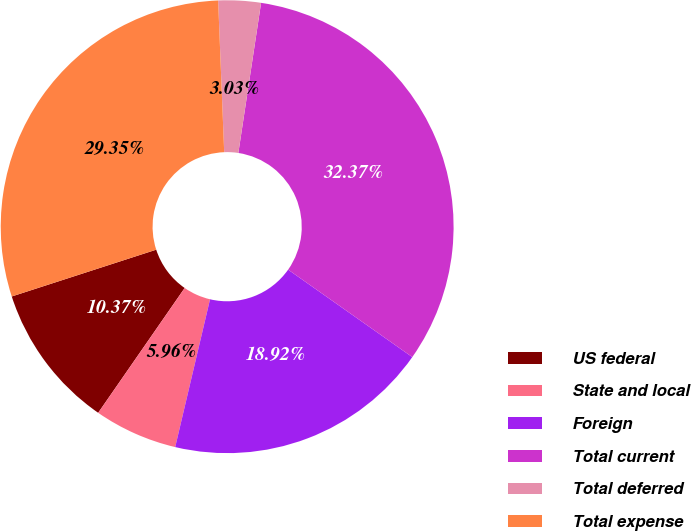<chart> <loc_0><loc_0><loc_500><loc_500><pie_chart><fcel>US federal<fcel>State and local<fcel>Foreign<fcel>Total current<fcel>Total deferred<fcel>Total expense<nl><fcel>10.37%<fcel>5.96%<fcel>18.92%<fcel>32.37%<fcel>3.03%<fcel>29.35%<nl></chart> 